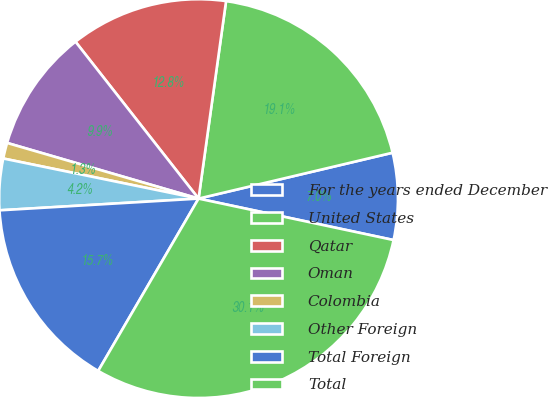Convert chart to OTSL. <chart><loc_0><loc_0><loc_500><loc_500><pie_chart><fcel>For the years ended December<fcel>United States<fcel>Qatar<fcel>Oman<fcel>Colombia<fcel>Other Foreign<fcel>Total Foreign<fcel>Total<nl><fcel>7.03%<fcel>19.1%<fcel>12.79%<fcel>9.91%<fcel>1.28%<fcel>4.16%<fcel>15.67%<fcel>30.06%<nl></chart> 